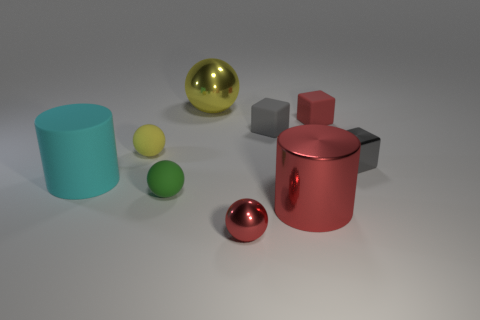There is a large metallic object in front of the big cyan object; does it have the same color as the large matte object?
Offer a very short reply. No. The tiny red object on the right side of the metal object that is in front of the big metallic thing in front of the red rubber thing is made of what material?
Offer a terse response. Rubber. Does the large ball have the same material as the small yellow thing?
Make the answer very short. No. What number of spheres are either large red things or small red rubber objects?
Give a very brief answer. 0. What is the color of the object that is in front of the metal cylinder?
Keep it short and to the point. Red. How many rubber things are tiny yellow things or tiny gray blocks?
Give a very brief answer. 2. The ball to the right of the shiny ball behind the big cyan rubber cylinder is made of what material?
Your answer should be compact. Metal. What is the material of the tiny ball that is the same color as the large metal cylinder?
Your answer should be very brief. Metal. The rubber cylinder is what color?
Provide a short and direct response. Cyan. Is there a small yellow rubber sphere that is to the right of the red object that is behind the cyan rubber cylinder?
Your response must be concise. No. 